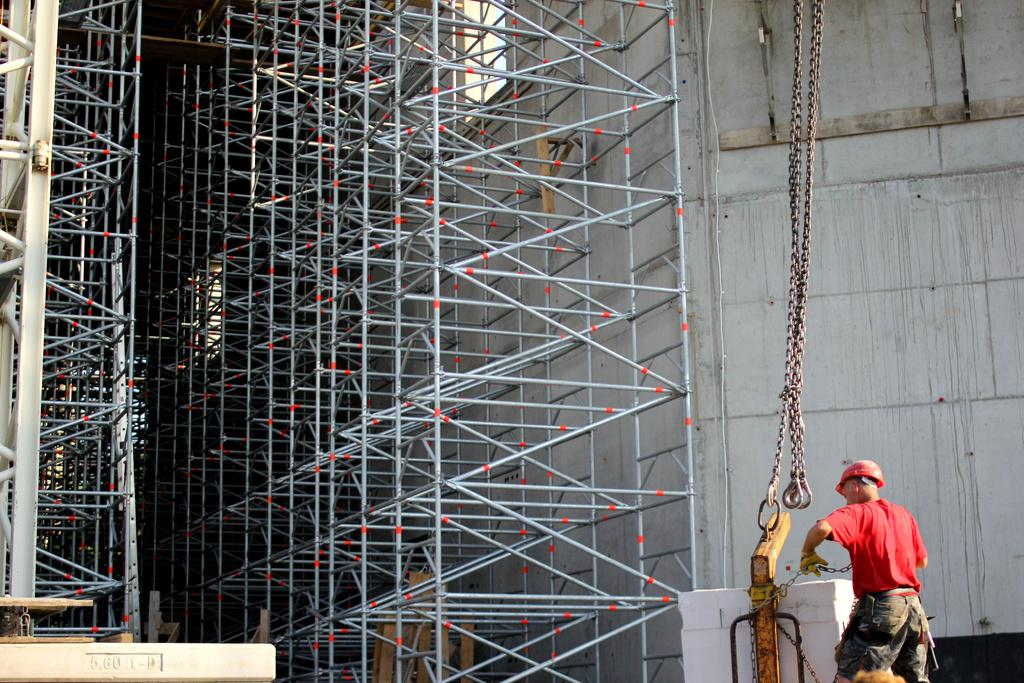What is the main subject in the foreground of the image? There is a person in the foreground of the image. What is the person holding in their hand? The person is holding an object in their hand. What can be seen in the background of the image? There are metal rods and a wall in the background of the image. What type of tub is visible in the image? There is no tub present in the image. What form does the base of the metal rods take in the image? The image does not provide enough information to determine the form of the base of the metal rods. 